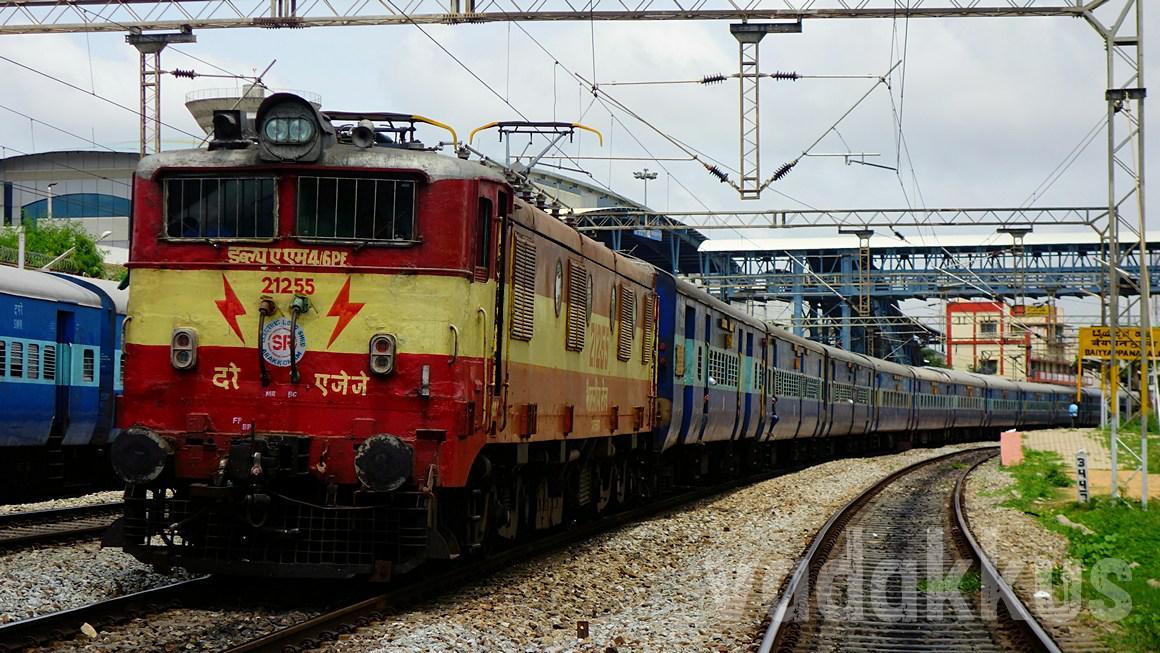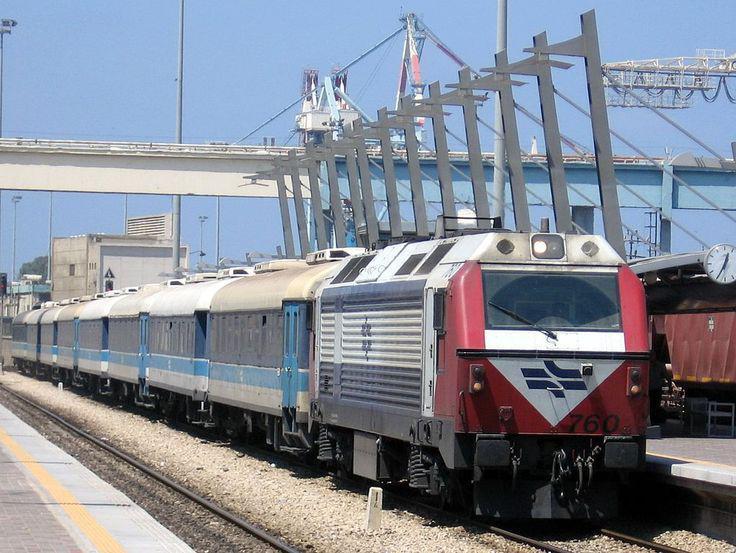The first image is the image on the left, the second image is the image on the right. Analyze the images presented: Is the assertion "The train in the image on the right has a single windshield." valid? Answer yes or no. Yes. The first image is the image on the left, the second image is the image on the right. Considering the images on both sides, is "A train is on a track next to bare-branched trees and a house with a peaked roof in one image." valid? Answer yes or no. No. 